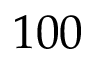<formula> <loc_0><loc_0><loc_500><loc_500>1 0 0</formula> 